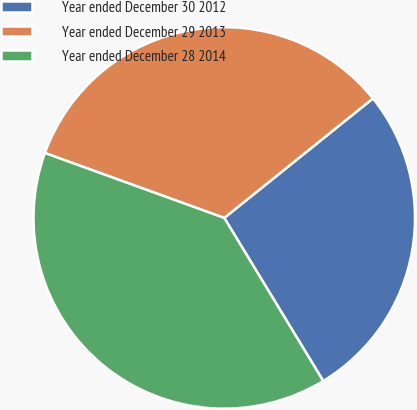Convert chart to OTSL. <chart><loc_0><loc_0><loc_500><loc_500><pie_chart><fcel>Year ended December 30 2012<fcel>Year ended December 29 2013<fcel>Year ended December 28 2014<nl><fcel>27.09%<fcel>33.7%<fcel>39.21%<nl></chart> 